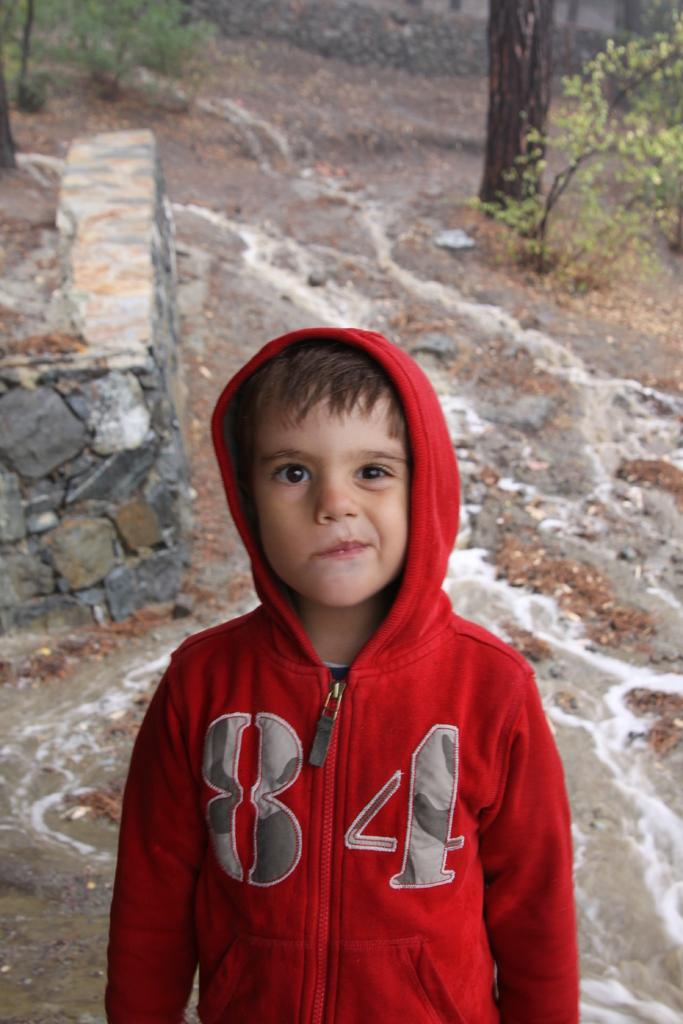Provide a one-sentence caption for the provided image. A young boy is shown outside wearing a red sweatshirt with the number 84 on it. 